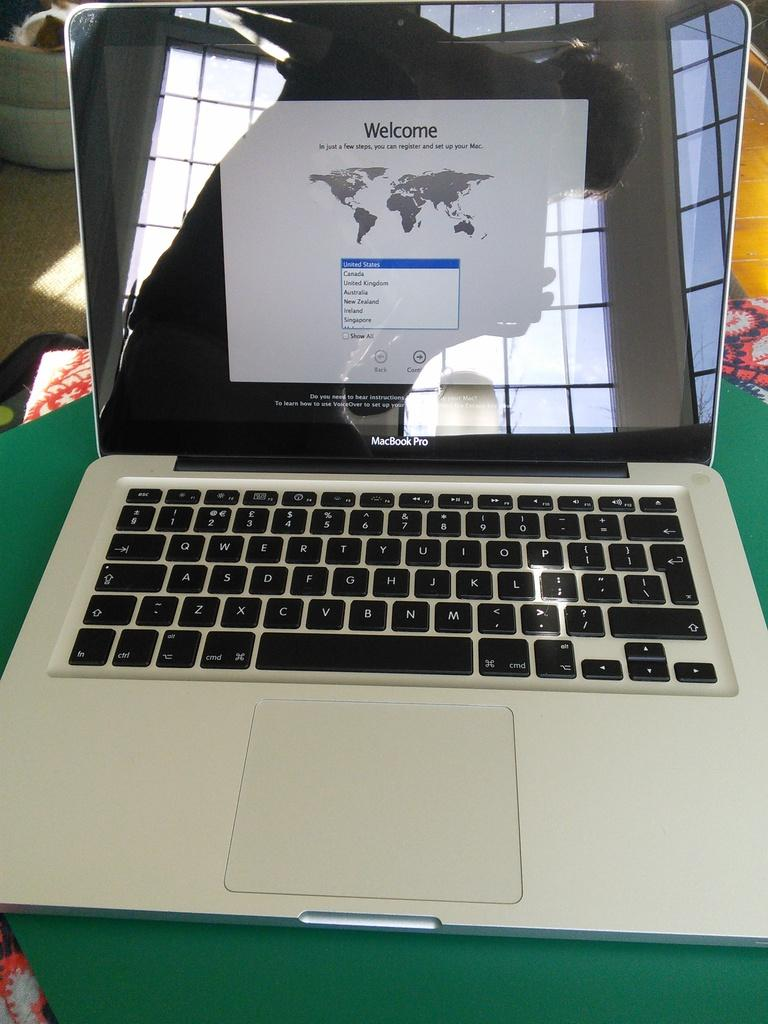<image>
Provide a brief description of the given image. The welcome screen is showing for an apple registration. 